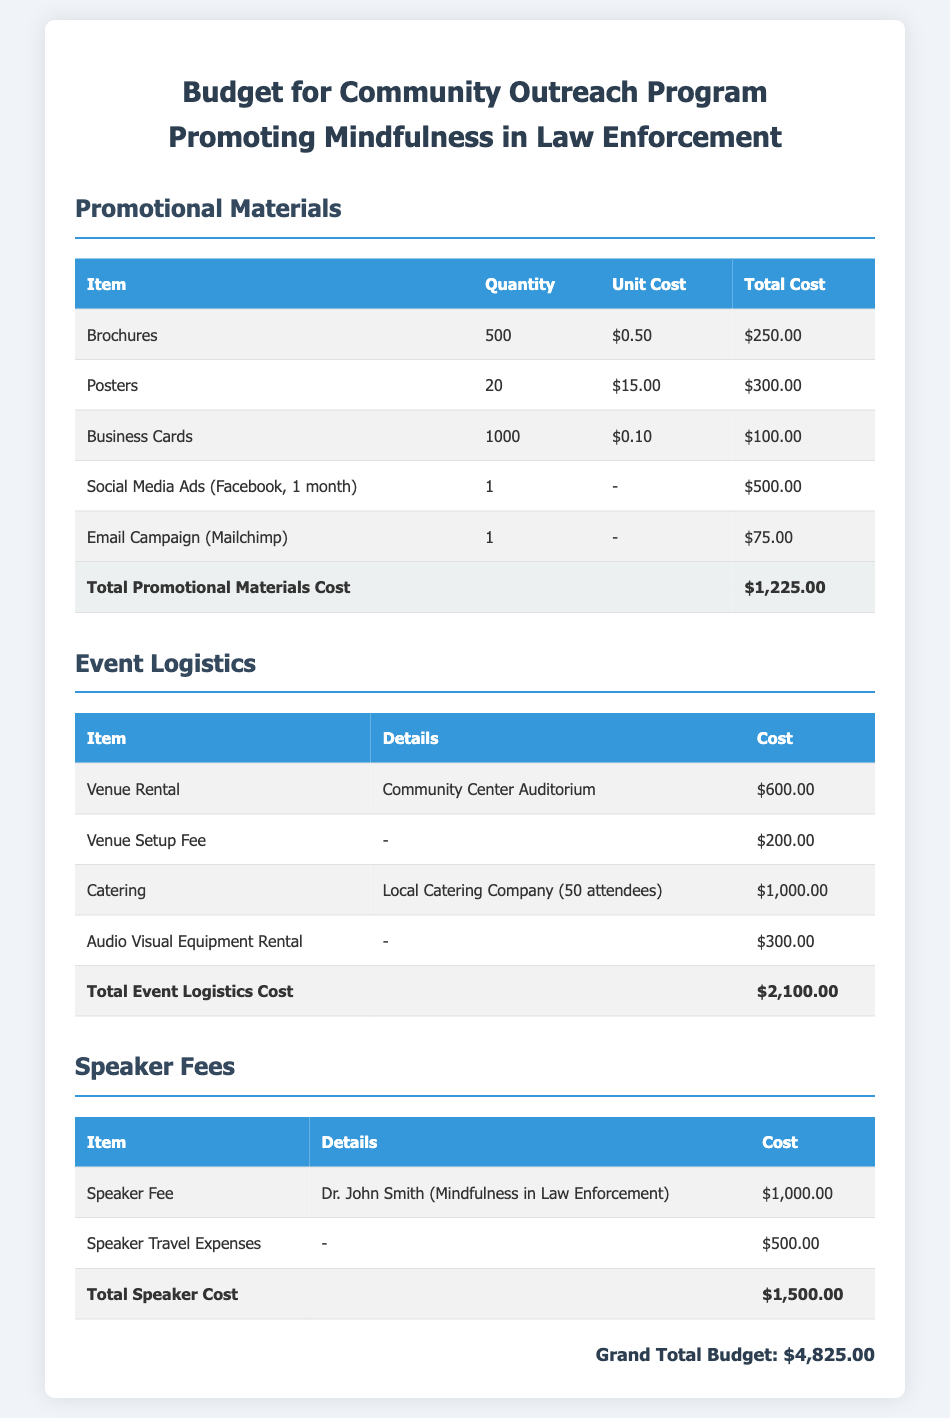What is the total cost of promotional materials? The total cost of promotional materials is stated in the document under the corresponding section, which is $1,225.00.
Answer: $1,225.00 How much is allocated for venue rental? The document specifies the venue rental cost under event logistics, which is $600.00.
Answer: $600.00 Who is the speaker for the program? The document lists Dr. John Smith as the speaker for the program under speaker fees.
Answer: Dr. John Smith What is the total cost for event logistics? The total cost for event logistics is presented in the event logistics section, which amounts to $2,100.00.
Answer: $2,100.00 How much are the speaker travel expenses? The travel expenses for the speaker are detailed in the speaker fees section, which shows a cost of $500.00.
Answer: $500.00 What is the grand total budget? The grand total budget is provided at the end of the document, which sums up all the expenses to $4,825.00.
Answer: $4,825.00 How many brochures are being printed? The number of brochures is indicated in the promotional materials section, showing a quantity of 500.
Answer: 500 What is the cost of catering? The catering cost is mentioned in the event logistics section, which states it as $1,000.00.
Answer: $1,000.00 What type of advertising is included? The document mentions social media ads in the promotional materials section, noting it as Facebook ads for one month.
Answer: Facebook ads (1 month) 